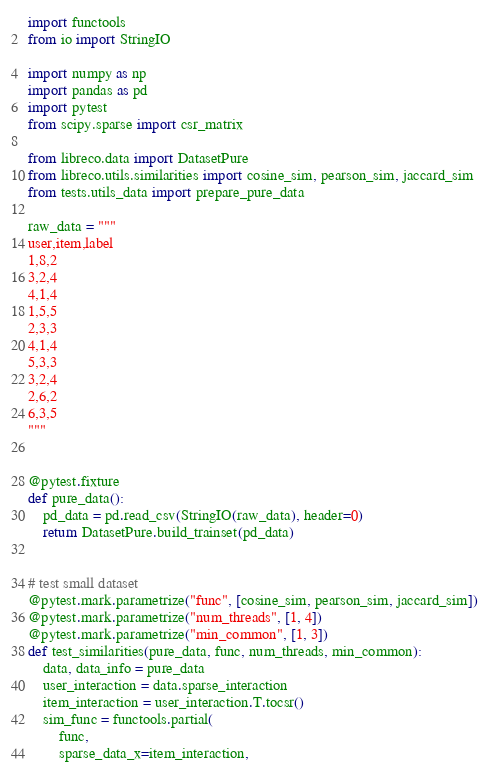Convert code to text. <code><loc_0><loc_0><loc_500><loc_500><_Python_>import functools
from io import StringIO

import numpy as np
import pandas as pd
import pytest
from scipy.sparse import csr_matrix

from libreco.data import DatasetPure
from libreco.utils.similarities import cosine_sim, pearson_sim, jaccard_sim
from tests.utils_data import prepare_pure_data

raw_data = """
user,item,label
1,8,2
3,2,4
4,1,4
1,5,5
2,3,3
4,1,4
5,3,3
3,2,4
2,6,2
6,3,5
"""


@pytest.fixture
def pure_data():
    pd_data = pd.read_csv(StringIO(raw_data), header=0)
    return DatasetPure.build_trainset(pd_data)


# test small dataset
@pytest.mark.parametrize("func", [cosine_sim, pearson_sim, jaccard_sim])
@pytest.mark.parametrize("num_threads", [1, 4])
@pytest.mark.parametrize("min_common", [1, 3])
def test_similarities(pure_data, func, num_threads, min_common):
    data, data_info = pure_data
    user_interaction = data.sparse_interaction
    item_interaction = user_interaction.T.tocsr()
    sim_func = functools.partial(
        func,
        sparse_data_x=item_interaction,</code> 